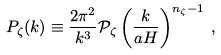Convert formula to latex. <formula><loc_0><loc_0><loc_500><loc_500>P _ { \zeta } ( k ) \equiv \frac { 2 \pi ^ { 2 } } { k ^ { 3 } } \mathcal { P } _ { \zeta } \left ( \frac { k } { a H } \right ) ^ { n _ { \zeta } - 1 } \, ,</formula> 